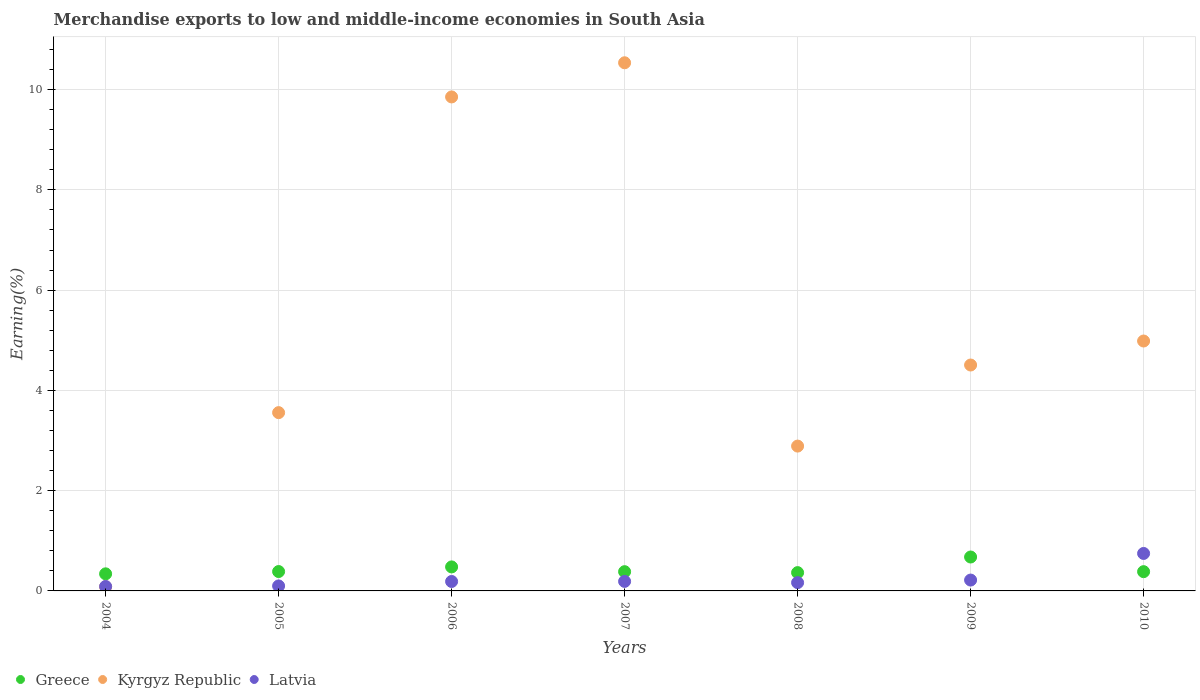What is the percentage of amount earned from merchandise exports in Latvia in 2009?
Your answer should be compact. 0.22. Across all years, what is the maximum percentage of amount earned from merchandise exports in Greece?
Offer a terse response. 0.68. Across all years, what is the minimum percentage of amount earned from merchandise exports in Latvia?
Offer a very short reply. 0.09. In which year was the percentage of amount earned from merchandise exports in Kyrgyz Republic maximum?
Provide a short and direct response. 2007. In which year was the percentage of amount earned from merchandise exports in Latvia minimum?
Offer a terse response. 2004. What is the total percentage of amount earned from merchandise exports in Kyrgyz Republic in the graph?
Make the answer very short. 36.41. What is the difference between the percentage of amount earned from merchandise exports in Latvia in 2006 and that in 2010?
Keep it short and to the point. -0.56. What is the difference between the percentage of amount earned from merchandise exports in Latvia in 2005 and the percentage of amount earned from merchandise exports in Greece in 2009?
Provide a short and direct response. -0.58. What is the average percentage of amount earned from merchandise exports in Greece per year?
Your answer should be compact. 0.43. In the year 2005, what is the difference between the percentage of amount earned from merchandise exports in Kyrgyz Republic and percentage of amount earned from merchandise exports in Latvia?
Keep it short and to the point. 3.46. In how many years, is the percentage of amount earned from merchandise exports in Greece greater than 6 %?
Your answer should be compact. 0. What is the ratio of the percentage of amount earned from merchandise exports in Latvia in 2004 to that in 2006?
Your answer should be compact. 0.47. Is the percentage of amount earned from merchandise exports in Latvia in 2005 less than that in 2006?
Make the answer very short. Yes. What is the difference between the highest and the second highest percentage of amount earned from merchandise exports in Latvia?
Provide a succinct answer. 0.53. What is the difference between the highest and the lowest percentage of amount earned from merchandise exports in Greece?
Provide a succinct answer. 0.34. Is the sum of the percentage of amount earned from merchandise exports in Kyrgyz Republic in 2005 and 2008 greater than the maximum percentage of amount earned from merchandise exports in Latvia across all years?
Keep it short and to the point. Yes. Is it the case that in every year, the sum of the percentage of amount earned from merchandise exports in Greece and percentage of amount earned from merchandise exports in Kyrgyz Republic  is greater than the percentage of amount earned from merchandise exports in Latvia?
Provide a succinct answer. Yes. Does the percentage of amount earned from merchandise exports in Latvia monotonically increase over the years?
Offer a very short reply. No. Is the percentage of amount earned from merchandise exports in Latvia strictly less than the percentage of amount earned from merchandise exports in Greece over the years?
Give a very brief answer. No. How many years are there in the graph?
Your answer should be compact. 7. What is the difference between two consecutive major ticks on the Y-axis?
Your answer should be very brief. 2. Does the graph contain grids?
Ensure brevity in your answer.  Yes. How many legend labels are there?
Your answer should be compact. 3. How are the legend labels stacked?
Provide a short and direct response. Horizontal. What is the title of the graph?
Ensure brevity in your answer.  Merchandise exports to low and middle-income economies in South Asia. Does "Mongolia" appear as one of the legend labels in the graph?
Offer a very short reply. No. What is the label or title of the Y-axis?
Make the answer very short. Earning(%). What is the Earning(%) in Greece in 2004?
Make the answer very short. 0.34. What is the Earning(%) in Kyrgyz Republic in 2004?
Offer a very short reply. 0.08. What is the Earning(%) of Latvia in 2004?
Ensure brevity in your answer.  0.09. What is the Earning(%) in Greece in 2005?
Make the answer very short. 0.39. What is the Earning(%) in Kyrgyz Republic in 2005?
Provide a succinct answer. 3.56. What is the Earning(%) of Latvia in 2005?
Ensure brevity in your answer.  0.1. What is the Earning(%) of Greece in 2006?
Keep it short and to the point. 0.48. What is the Earning(%) of Kyrgyz Republic in 2006?
Provide a succinct answer. 9.85. What is the Earning(%) of Latvia in 2006?
Ensure brevity in your answer.  0.19. What is the Earning(%) in Greece in 2007?
Provide a succinct answer. 0.38. What is the Earning(%) of Kyrgyz Republic in 2007?
Your answer should be compact. 10.54. What is the Earning(%) of Latvia in 2007?
Provide a short and direct response. 0.19. What is the Earning(%) of Greece in 2008?
Your answer should be very brief. 0.37. What is the Earning(%) of Kyrgyz Republic in 2008?
Keep it short and to the point. 2.89. What is the Earning(%) in Latvia in 2008?
Your answer should be compact. 0.17. What is the Earning(%) of Greece in 2009?
Provide a short and direct response. 0.68. What is the Earning(%) in Kyrgyz Republic in 2009?
Offer a terse response. 4.51. What is the Earning(%) in Latvia in 2009?
Make the answer very short. 0.22. What is the Earning(%) in Greece in 2010?
Offer a very short reply. 0.38. What is the Earning(%) of Kyrgyz Republic in 2010?
Keep it short and to the point. 4.99. What is the Earning(%) in Latvia in 2010?
Provide a succinct answer. 0.75. Across all years, what is the maximum Earning(%) in Greece?
Your answer should be compact. 0.68. Across all years, what is the maximum Earning(%) of Kyrgyz Republic?
Your answer should be very brief. 10.54. Across all years, what is the maximum Earning(%) of Latvia?
Your response must be concise. 0.75. Across all years, what is the minimum Earning(%) of Greece?
Your answer should be very brief. 0.34. Across all years, what is the minimum Earning(%) in Kyrgyz Republic?
Your response must be concise. 0.08. Across all years, what is the minimum Earning(%) of Latvia?
Ensure brevity in your answer.  0.09. What is the total Earning(%) in Greece in the graph?
Your answer should be very brief. 3.02. What is the total Earning(%) of Kyrgyz Republic in the graph?
Your answer should be compact. 36.41. What is the total Earning(%) in Latvia in the graph?
Ensure brevity in your answer.  1.7. What is the difference between the Earning(%) of Greece in 2004 and that in 2005?
Give a very brief answer. -0.05. What is the difference between the Earning(%) in Kyrgyz Republic in 2004 and that in 2005?
Give a very brief answer. -3.47. What is the difference between the Earning(%) of Latvia in 2004 and that in 2005?
Offer a terse response. -0.01. What is the difference between the Earning(%) of Greece in 2004 and that in 2006?
Give a very brief answer. -0.14. What is the difference between the Earning(%) in Kyrgyz Republic in 2004 and that in 2006?
Offer a terse response. -9.77. What is the difference between the Earning(%) in Latvia in 2004 and that in 2006?
Offer a very short reply. -0.1. What is the difference between the Earning(%) in Greece in 2004 and that in 2007?
Keep it short and to the point. -0.04. What is the difference between the Earning(%) of Kyrgyz Republic in 2004 and that in 2007?
Offer a very short reply. -10.45. What is the difference between the Earning(%) of Latvia in 2004 and that in 2007?
Keep it short and to the point. -0.1. What is the difference between the Earning(%) in Greece in 2004 and that in 2008?
Keep it short and to the point. -0.02. What is the difference between the Earning(%) of Kyrgyz Republic in 2004 and that in 2008?
Provide a short and direct response. -2.81. What is the difference between the Earning(%) in Latvia in 2004 and that in 2008?
Give a very brief answer. -0.08. What is the difference between the Earning(%) in Greece in 2004 and that in 2009?
Your answer should be compact. -0.34. What is the difference between the Earning(%) in Kyrgyz Republic in 2004 and that in 2009?
Your answer should be very brief. -4.42. What is the difference between the Earning(%) in Latvia in 2004 and that in 2009?
Provide a short and direct response. -0.13. What is the difference between the Earning(%) in Greece in 2004 and that in 2010?
Offer a very short reply. -0.04. What is the difference between the Earning(%) of Kyrgyz Republic in 2004 and that in 2010?
Ensure brevity in your answer.  -4.9. What is the difference between the Earning(%) in Latvia in 2004 and that in 2010?
Your response must be concise. -0.66. What is the difference between the Earning(%) in Greece in 2005 and that in 2006?
Ensure brevity in your answer.  -0.09. What is the difference between the Earning(%) in Kyrgyz Republic in 2005 and that in 2006?
Provide a succinct answer. -6.3. What is the difference between the Earning(%) in Latvia in 2005 and that in 2006?
Ensure brevity in your answer.  -0.09. What is the difference between the Earning(%) of Greece in 2005 and that in 2007?
Keep it short and to the point. 0. What is the difference between the Earning(%) in Kyrgyz Republic in 2005 and that in 2007?
Your answer should be compact. -6.98. What is the difference between the Earning(%) of Latvia in 2005 and that in 2007?
Offer a very short reply. -0.09. What is the difference between the Earning(%) of Greece in 2005 and that in 2008?
Make the answer very short. 0.02. What is the difference between the Earning(%) in Kyrgyz Republic in 2005 and that in 2008?
Your answer should be compact. 0.67. What is the difference between the Earning(%) of Latvia in 2005 and that in 2008?
Offer a terse response. -0.07. What is the difference between the Earning(%) in Greece in 2005 and that in 2009?
Ensure brevity in your answer.  -0.29. What is the difference between the Earning(%) in Kyrgyz Republic in 2005 and that in 2009?
Provide a succinct answer. -0.95. What is the difference between the Earning(%) of Latvia in 2005 and that in 2009?
Keep it short and to the point. -0.12. What is the difference between the Earning(%) of Greece in 2005 and that in 2010?
Keep it short and to the point. 0. What is the difference between the Earning(%) in Kyrgyz Republic in 2005 and that in 2010?
Provide a succinct answer. -1.43. What is the difference between the Earning(%) of Latvia in 2005 and that in 2010?
Ensure brevity in your answer.  -0.65. What is the difference between the Earning(%) of Greece in 2006 and that in 2007?
Keep it short and to the point. 0.1. What is the difference between the Earning(%) of Kyrgyz Republic in 2006 and that in 2007?
Provide a succinct answer. -0.68. What is the difference between the Earning(%) in Latvia in 2006 and that in 2007?
Your response must be concise. -0. What is the difference between the Earning(%) of Greece in 2006 and that in 2008?
Ensure brevity in your answer.  0.11. What is the difference between the Earning(%) in Kyrgyz Republic in 2006 and that in 2008?
Ensure brevity in your answer.  6.97. What is the difference between the Earning(%) of Latvia in 2006 and that in 2008?
Your response must be concise. 0.02. What is the difference between the Earning(%) of Greece in 2006 and that in 2009?
Your answer should be compact. -0.2. What is the difference between the Earning(%) in Kyrgyz Republic in 2006 and that in 2009?
Provide a succinct answer. 5.35. What is the difference between the Earning(%) of Latvia in 2006 and that in 2009?
Your answer should be compact. -0.03. What is the difference between the Earning(%) of Greece in 2006 and that in 2010?
Your answer should be very brief. 0.09. What is the difference between the Earning(%) of Kyrgyz Republic in 2006 and that in 2010?
Provide a short and direct response. 4.87. What is the difference between the Earning(%) in Latvia in 2006 and that in 2010?
Make the answer very short. -0.56. What is the difference between the Earning(%) of Greece in 2007 and that in 2008?
Make the answer very short. 0.02. What is the difference between the Earning(%) of Kyrgyz Republic in 2007 and that in 2008?
Provide a short and direct response. 7.65. What is the difference between the Earning(%) in Latvia in 2007 and that in 2008?
Provide a succinct answer. 0.02. What is the difference between the Earning(%) in Greece in 2007 and that in 2009?
Make the answer very short. -0.29. What is the difference between the Earning(%) in Kyrgyz Republic in 2007 and that in 2009?
Provide a succinct answer. 6.03. What is the difference between the Earning(%) of Latvia in 2007 and that in 2009?
Make the answer very short. -0.03. What is the difference between the Earning(%) in Greece in 2007 and that in 2010?
Offer a terse response. -0. What is the difference between the Earning(%) in Kyrgyz Republic in 2007 and that in 2010?
Ensure brevity in your answer.  5.55. What is the difference between the Earning(%) of Latvia in 2007 and that in 2010?
Ensure brevity in your answer.  -0.56. What is the difference between the Earning(%) in Greece in 2008 and that in 2009?
Your answer should be very brief. -0.31. What is the difference between the Earning(%) in Kyrgyz Republic in 2008 and that in 2009?
Make the answer very short. -1.62. What is the difference between the Earning(%) in Latvia in 2008 and that in 2009?
Give a very brief answer. -0.05. What is the difference between the Earning(%) of Greece in 2008 and that in 2010?
Offer a terse response. -0.02. What is the difference between the Earning(%) in Kyrgyz Republic in 2008 and that in 2010?
Your answer should be compact. -2.1. What is the difference between the Earning(%) of Latvia in 2008 and that in 2010?
Your response must be concise. -0.58. What is the difference between the Earning(%) of Greece in 2009 and that in 2010?
Provide a short and direct response. 0.29. What is the difference between the Earning(%) in Kyrgyz Republic in 2009 and that in 2010?
Your answer should be very brief. -0.48. What is the difference between the Earning(%) in Latvia in 2009 and that in 2010?
Give a very brief answer. -0.53. What is the difference between the Earning(%) in Greece in 2004 and the Earning(%) in Kyrgyz Republic in 2005?
Offer a very short reply. -3.22. What is the difference between the Earning(%) in Greece in 2004 and the Earning(%) in Latvia in 2005?
Make the answer very short. 0.24. What is the difference between the Earning(%) of Kyrgyz Republic in 2004 and the Earning(%) of Latvia in 2005?
Make the answer very short. -0.02. What is the difference between the Earning(%) of Greece in 2004 and the Earning(%) of Kyrgyz Republic in 2006?
Your response must be concise. -9.51. What is the difference between the Earning(%) of Greece in 2004 and the Earning(%) of Latvia in 2006?
Provide a succinct answer. 0.15. What is the difference between the Earning(%) in Kyrgyz Republic in 2004 and the Earning(%) in Latvia in 2006?
Keep it short and to the point. -0.11. What is the difference between the Earning(%) in Greece in 2004 and the Earning(%) in Kyrgyz Republic in 2007?
Your answer should be very brief. -10.19. What is the difference between the Earning(%) of Greece in 2004 and the Earning(%) of Latvia in 2007?
Provide a succinct answer. 0.15. What is the difference between the Earning(%) in Kyrgyz Republic in 2004 and the Earning(%) in Latvia in 2007?
Your answer should be compact. -0.11. What is the difference between the Earning(%) in Greece in 2004 and the Earning(%) in Kyrgyz Republic in 2008?
Make the answer very short. -2.55. What is the difference between the Earning(%) of Greece in 2004 and the Earning(%) of Latvia in 2008?
Offer a terse response. 0.18. What is the difference between the Earning(%) in Kyrgyz Republic in 2004 and the Earning(%) in Latvia in 2008?
Your answer should be very brief. -0.08. What is the difference between the Earning(%) in Greece in 2004 and the Earning(%) in Kyrgyz Republic in 2009?
Offer a terse response. -4.17. What is the difference between the Earning(%) of Greece in 2004 and the Earning(%) of Latvia in 2009?
Your response must be concise. 0.12. What is the difference between the Earning(%) of Kyrgyz Republic in 2004 and the Earning(%) of Latvia in 2009?
Offer a terse response. -0.13. What is the difference between the Earning(%) in Greece in 2004 and the Earning(%) in Kyrgyz Republic in 2010?
Offer a terse response. -4.64. What is the difference between the Earning(%) in Greece in 2004 and the Earning(%) in Latvia in 2010?
Your answer should be compact. -0.41. What is the difference between the Earning(%) in Kyrgyz Republic in 2004 and the Earning(%) in Latvia in 2010?
Ensure brevity in your answer.  -0.67. What is the difference between the Earning(%) in Greece in 2005 and the Earning(%) in Kyrgyz Republic in 2006?
Your answer should be compact. -9.47. What is the difference between the Earning(%) in Greece in 2005 and the Earning(%) in Latvia in 2006?
Your answer should be compact. 0.2. What is the difference between the Earning(%) of Kyrgyz Republic in 2005 and the Earning(%) of Latvia in 2006?
Ensure brevity in your answer.  3.37. What is the difference between the Earning(%) of Greece in 2005 and the Earning(%) of Kyrgyz Republic in 2007?
Keep it short and to the point. -10.15. What is the difference between the Earning(%) in Greece in 2005 and the Earning(%) in Latvia in 2007?
Your response must be concise. 0.2. What is the difference between the Earning(%) of Kyrgyz Republic in 2005 and the Earning(%) of Latvia in 2007?
Provide a short and direct response. 3.37. What is the difference between the Earning(%) of Greece in 2005 and the Earning(%) of Kyrgyz Republic in 2008?
Your answer should be compact. -2.5. What is the difference between the Earning(%) of Greece in 2005 and the Earning(%) of Latvia in 2008?
Your response must be concise. 0.22. What is the difference between the Earning(%) of Kyrgyz Republic in 2005 and the Earning(%) of Latvia in 2008?
Make the answer very short. 3.39. What is the difference between the Earning(%) in Greece in 2005 and the Earning(%) in Kyrgyz Republic in 2009?
Ensure brevity in your answer.  -4.12. What is the difference between the Earning(%) in Greece in 2005 and the Earning(%) in Latvia in 2009?
Your answer should be very brief. 0.17. What is the difference between the Earning(%) of Kyrgyz Republic in 2005 and the Earning(%) of Latvia in 2009?
Give a very brief answer. 3.34. What is the difference between the Earning(%) in Greece in 2005 and the Earning(%) in Kyrgyz Republic in 2010?
Make the answer very short. -4.6. What is the difference between the Earning(%) in Greece in 2005 and the Earning(%) in Latvia in 2010?
Ensure brevity in your answer.  -0.36. What is the difference between the Earning(%) of Kyrgyz Republic in 2005 and the Earning(%) of Latvia in 2010?
Provide a succinct answer. 2.81. What is the difference between the Earning(%) of Greece in 2006 and the Earning(%) of Kyrgyz Republic in 2007?
Your response must be concise. -10.06. What is the difference between the Earning(%) of Greece in 2006 and the Earning(%) of Latvia in 2007?
Make the answer very short. 0.29. What is the difference between the Earning(%) in Kyrgyz Republic in 2006 and the Earning(%) in Latvia in 2007?
Your answer should be compact. 9.66. What is the difference between the Earning(%) of Greece in 2006 and the Earning(%) of Kyrgyz Republic in 2008?
Give a very brief answer. -2.41. What is the difference between the Earning(%) of Greece in 2006 and the Earning(%) of Latvia in 2008?
Provide a short and direct response. 0.31. What is the difference between the Earning(%) of Kyrgyz Republic in 2006 and the Earning(%) of Latvia in 2008?
Give a very brief answer. 9.69. What is the difference between the Earning(%) of Greece in 2006 and the Earning(%) of Kyrgyz Republic in 2009?
Your response must be concise. -4.03. What is the difference between the Earning(%) of Greece in 2006 and the Earning(%) of Latvia in 2009?
Offer a very short reply. 0.26. What is the difference between the Earning(%) in Kyrgyz Republic in 2006 and the Earning(%) in Latvia in 2009?
Give a very brief answer. 9.64. What is the difference between the Earning(%) in Greece in 2006 and the Earning(%) in Kyrgyz Republic in 2010?
Your response must be concise. -4.51. What is the difference between the Earning(%) in Greece in 2006 and the Earning(%) in Latvia in 2010?
Provide a succinct answer. -0.27. What is the difference between the Earning(%) in Kyrgyz Republic in 2006 and the Earning(%) in Latvia in 2010?
Give a very brief answer. 9.11. What is the difference between the Earning(%) in Greece in 2007 and the Earning(%) in Kyrgyz Republic in 2008?
Your answer should be compact. -2.51. What is the difference between the Earning(%) in Greece in 2007 and the Earning(%) in Latvia in 2008?
Offer a very short reply. 0.22. What is the difference between the Earning(%) of Kyrgyz Republic in 2007 and the Earning(%) of Latvia in 2008?
Offer a terse response. 10.37. What is the difference between the Earning(%) of Greece in 2007 and the Earning(%) of Kyrgyz Republic in 2009?
Provide a succinct answer. -4.12. What is the difference between the Earning(%) of Greece in 2007 and the Earning(%) of Latvia in 2009?
Offer a terse response. 0.17. What is the difference between the Earning(%) in Kyrgyz Republic in 2007 and the Earning(%) in Latvia in 2009?
Offer a very short reply. 10.32. What is the difference between the Earning(%) of Greece in 2007 and the Earning(%) of Kyrgyz Republic in 2010?
Offer a terse response. -4.6. What is the difference between the Earning(%) of Greece in 2007 and the Earning(%) of Latvia in 2010?
Provide a short and direct response. -0.36. What is the difference between the Earning(%) in Kyrgyz Republic in 2007 and the Earning(%) in Latvia in 2010?
Your answer should be very brief. 9.79. What is the difference between the Earning(%) in Greece in 2008 and the Earning(%) in Kyrgyz Republic in 2009?
Provide a succinct answer. -4.14. What is the difference between the Earning(%) of Greece in 2008 and the Earning(%) of Latvia in 2009?
Offer a terse response. 0.15. What is the difference between the Earning(%) in Kyrgyz Republic in 2008 and the Earning(%) in Latvia in 2009?
Your response must be concise. 2.67. What is the difference between the Earning(%) in Greece in 2008 and the Earning(%) in Kyrgyz Republic in 2010?
Offer a terse response. -4.62. What is the difference between the Earning(%) of Greece in 2008 and the Earning(%) of Latvia in 2010?
Ensure brevity in your answer.  -0.38. What is the difference between the Earning(%) of Kyrgyz Republic in 2008 and the Earning(%) of Latvia in 2010?
Keep it short and to the point. 2.14. What is the difference between the Earning(%) in Greece in 2009 and the Earning(%) in Kyrgyz Republic in 2010?
Provide a succinct answer. -4.31. What is the difference between the Earning(%) in Greece in 2009 and the Earning(%) in Latvia in 2010?
Give a very brief answer. -0.07. What is the difference between the Earning(%) of Kyrgyz Republic in 2009 and the Earning(%) of Latvia in 2010?
Offer a very short reply. 3.76. What is the average Earning(%) in Greece per year?
Your answer should be very brief. 0.43. What is the average Earning(%) in Kyrgyz Republic per year?
Ensure brevity in your answer.  5.2. What is the average Earning(%) of Latvia per year?
Your answer should be very brief. 0.24. In the year 2004, what is the difference between the Earning(%) of Greece and Earning(%) of Kyrgyz Republic?
Offer a very short reply. 0.26. In the year 2004, what is the difference between the Earning(%) in Greece and Earning(%) in Latvia?
Give a very brief answer. 0.25. In the year 2004, what is the difference between the Earning(%) in Kyrgyz Republic and Earning(%) in Latvia?
Make the answer very short. -0.01. In the year 2005, what is the difference between the Earning(%) of Greece and Earning(%) of Kyrgyz Republic?
Your answer should be compact. -3.17. In the year 2005, what is the difference between the Earning(%) of Greece and Earning(%) of Latvia?
Give a very brief answer. 0.29. In the year 2005, what is the difference between the Earning(%) in Kyrgyz Republic and Earning(%) in Latvia?
Provide a succinct answer. 3.46. In the year 2006, what is the difference between the Earning(%) in Greece and Earning(%) in Kyrgyz Republic?
Provide a short and direct response. -9.38. In the year 2006, what is the difference between the Earning(%) of Greece and Earning(%) of Latvia?
Your response must be concise. 0.29. In the year 2006, what is the difference between the Earning(%) of Kyrgyz Republic and Earning(%) of Latvia?
Ensure brevity in your answer.  9.67. In the year 2007, what is the difference between the Earning(%) of Greece and Earning(%) of Kyrgyz Republic?
Provide a short and direct response. -10.15. In the year 2007, what is the difference between the Earning(%) in Greece and Earning(%) in Latvia?
Offer a very short reply. 0.19. In the year 2007, what is the difference between the Earning(%) of Kyrgyz Republic and Earning(%) of Latvia?
Offer a very short reply. 10.35. In the year 2008, what is the difference between the Earning(%) in Greece and Earning(%) in Kyrgyz Republic?
Provide a short and direct response. -2.52. In the year 2008, what is the difference between the Earning(%) in Greece and Earning(%) in Latvia?
Offer a terse response. 0.2. In the year 2008, what is the difference between the Earning(%) of Kyrgyz Republic and Earning(%) of Latvia?
Your answer should be compact. 2.72. In the year 2009, what is the difference between the Earning(%) in Greece and Earning(%) in Kyrgyz Republic?
Your answer should be very brief. -3.83. In the year 2009, what is the difference between the Earning(%) of Greece and Earning(%) of Latvia?
Give a very brief answer. 0.46. In the year 2009, what is the difference between the Earning(%) in Kyrgyz Republic and Earning(%) in Latvia?
Offer a very short reply. 4.29. In the year 2010, what is the difference between the Earning(%) of Greece and Earning(%) of Kyrgyz Republic?
Ensure brevity in your answer.  -4.6. In the year 2010, what is the difference between the Earning(%) of Greece and Earning(%) of Latvia?
Your answer should be compact. -0.36. In the year 2010, what is the difference between the Earning(%) of Kyrgyz Republic and Earning(%) of Latvia?
Offer a very short reply. 4.24. What is the ratio of the Earning(%) of Greece in 2004 to that in 2005?
Make the answer very short. 0.88. What is the ratio of the Earning(%) in Kyrgyz Republic in 2004 to that in 2005?
Offer a terse response. 0.02. What is the ratio of the Earning(%) of Latvia in 2004 to that in 2005?
Offer a very short reply. 0.89. What is the ratio of the Earning(%) in Greece in 2004 to that in 2006?
Offer a very short reply. 0.71. What is the ratio of the Earning(%) in Kyrgyz Republic in 2004 to that in 2006?
Make the answer very short. 0.01. What is the ratio of the Earning(%) of Latvia in 2004 to that in 2006?
Provide a succinct answer. 0.47. What is the ratio of the Earning(%) in Greece in 2004 to that in 2007?
Offer a terse response. 0.89. What is the ratio of the Earning(%) in Kyrgyz Republic in 2004 to that in 2007?
Provide a succinct answer. 0.01. What is the ratio of the Earning(%) of Latvia in 2004 to that in 2007?
Your response must be concise. 0.47. What is the ratio of the Earning(%) of Greece in 2004 to that in 2008?
Make the answer very short. 0.93. What is the ratio of the Earning(%) in Kyrgyz Republic in 2004 to that in 2008?
Offer a very short reply. 0.03. What is the ratio of the Earning(%) of Latvia in 2004 to that in 2008?
Offer a very short reply. 0.54. What is the ratio of the Earning(%) of Greece in 2004 to that in 2009?
Offer a very short reply. 0.5. What is the ratio of the Earning(%) of Kyrgyz Republic in 2004 to that in 2009?
Give a very brief answer. 0.02. What is the ratio of the Earning(%) in Latvia in 2004 to that in 2009?
Give a very brief answer. 0.41. What is the ratio of the Earning(%) in Greece in 2004 to that in 2010?
Offer a very short reply. 0.89. What is the ratio of the Earning(%) in Kyrgyz Republic in 2004 to that in 2010?
Provide a short and direct response. 0.02. What is the ratio of the Earning(%) of Latvia in 2004 to that in 2010?
Keep it short and to the point. 0.12. What is the ratio of the Earning(%) in Greece in 2005 to that in 2006?
Make the answer very short. 0.81. What is the ratio of the Earning(%) in Kyrgyz Republic in 2005 to that in 2006?
Give a very brief answer. 0.36. What is the ratio of the Earning(%) of Latvia in 2005 to that in 2006?
Offer a terse response. 0.53. What is the ratio of the Earning(%) in Greece in 2005 to that in 2007?
Ensure brevity in your answer.  1.01. What is the ratio of the Earning(%) of Kyrgyz Republic in 2005 to that in 2007?
Provide a short and direct response. 0.34. What is the ratio of the Earning(%) of Latvia in 2005 to that in 2007?
Keep it short and to the point. 0.52. What is the ratio of the Earning(%) in Greece in 2005 to that in 2008?
Provide a succinct answer. 1.06. What is the ratio of the Earning(%) in Kyrgyz Republic in 2005 to that in 2008?
Your response must be concise. 1.23. What is the ratio of the Earning(%) in Latvia in 2005 to that in 2008?
Offer a terse response. 0.6. What is the ratio of the Earning(%) of Greece in 2005 to that in 2009?
Provide a succinct answer. 0.57. What is the ratio of the Earning(%) of Kyrgyz Republic in 2005 to that in 2009?
Your response must be concise. 0.79. What is the ratio of the Earning(%) in Latvia in 2005 to that in 2009?
Keep it short and to the point. 0.46. What is the ratio of the Earning(%) in Greece in 2005 to that in 2010?
Provide a short and direct response. 1.01. What is the ratio of the Earning(%) of Kyrgyz Republic in 2005 to that in 2010?
Offer a terse response. 0.71. What is the ratio of the Earning(%) in Latvia in 2005 to that in 2010?
Make the answer very short. 0.13. What is the ratio of the Earning(%) of Greece in 2006 to that in 2007?
Provide a succinct answer. 1.25. What is the ratio of the Earning(%) of Kyrgyz Republic in 2006 to that in 2007?
Give a very brief answer. 0.94. What is the ratio of the Earning(%) in Latvia in 2006 to that in 2007?
Offer a very short reply. 0.99. What is the ratio of the Earning(%) in Greece in 2006 to that in 2008?
Keep it short and to the point. 1.31. What is the ratio of the Earning(%) of Kyrgyz Republic in 2006 to that in 2008?
Your answer should be compact. 3.41. What is the ratio of the Earning(%) in Latvia in 2006 to that in 2008?
Ensure brevity in your answer.  1.14. What is the ratio of the Earning(%) in Greece in 2006 to that in 2009?
Provide a short and direct response. 0.71. What is the ratio of the Earning(%) of Kyrgyz Republic in 2006 to that in 2009?
Make the answer very short. 2.19. What is the ratio of the Earning(%) in Latvia in 2006 to that in 2009?
Ensure brevity in your answer.  0.87. What is the ratio of the Earning(%) of Greece in 2006 to that in 2010?
Offer a terse response. 1.25. What is the ratio of the Earning(%) in Kyrgyz Republic in 2006 to that in 2010?
Provide a succinct answer. 1.98. What is the ratio of the Earning(%) of Latvia in 2006 to that in 2010?
Your response must be concise. 0.25. What is the ratio of the Earning(%) in Greece in 2007 to that in 2008?
Keep it short and to the point. 1.05. What is the ratio of the Earning(%) in Kyrgyz Republic in 2007 to that in 2008?
Offer a terse response. 3.65. What is the ratio of the Earning(%) in Latvia in 2007 to that in 2008?
Provide a succinct answer. 1.15. What is the ratio of the Earning(%) in Greece in 2007 to that in 2009?
Your response must be concise. 0.57. What is the ratio of the Earning(%) in Kyrgyz Republic in 2007 to that in 2009?
Provide a succinct answer. 2.34. What is the ratio of the Earning(%) of Latvia in 2007 to that in 2009?
Make the answer very short. 0.88. What is the ratio of the Earning(%) in Kyrgyz Republic in 2007 to that in 2010?
Make the answer very short. 2.11. What is the ratio of the Earning(%) of Latvia in 2007 to that in 2010?
Keep it short and to the point. 0.25. What is the ratio of the Earning(%) of Greece in 2008 to that in 2009?
Give a very brief answer. 0.54. What is the ratio of the Earning(%) in Kyrgyz Republic in 2008 to that in 2009?
Provide a short and direct response. 0.64. What is the ratio of the Earning(%) in Latvia in 2008 to that in 2009?
Provide a short and direct response. 0.76. What is the ratio of the Earning(%) of Greece in 2008 to that in 2010?
Give a very brief answer. 0.95. What is the ratio of the Earning(%) of Kyrgyz Republic in 2008 to that in 2010?
Ensure brevity in your answer.  0.58. What is the ratio of the Earning(%) of Latvia in 2008 to that in 2010?
Keep it short and to the point. 0.22. What is the ratio of the Earning(%) in Greece in 2009 to that in 2010?
Offer a terse response. 1.76. What is the ratio of the Earning(%) of Kyrgyz Republic in 2009 to that in 2010?
Give a very brief answer. 0.9. What is the ratio of the Earning(%) of Latvia in 2009 to that in 2010?
Offer a very short reply. 0.29. What is the difference between the highest and the second highest Earning(%) of Greece?
Your answer should be compact. 0.2. What is the difference between the highest and the second highest Earning(%) in Kyrgyz Republic?
Make the answer very short. 0.68. What is the difference between the highest and the second highest Earning(%) in Latvia?
Make the answer very short. 0.53. What is the difference between the highest and the lowest Earning(%) in Greece?
Your response must be concise. 0.34. What is the difference between the highest and the lowest Earning(%) of Kyrgyz Republic?
Give a very brief answer. 10.45. What is the difference between the highest and the lowest Earning(%) in Latvia?
Your answer should be compact. 0.66. 